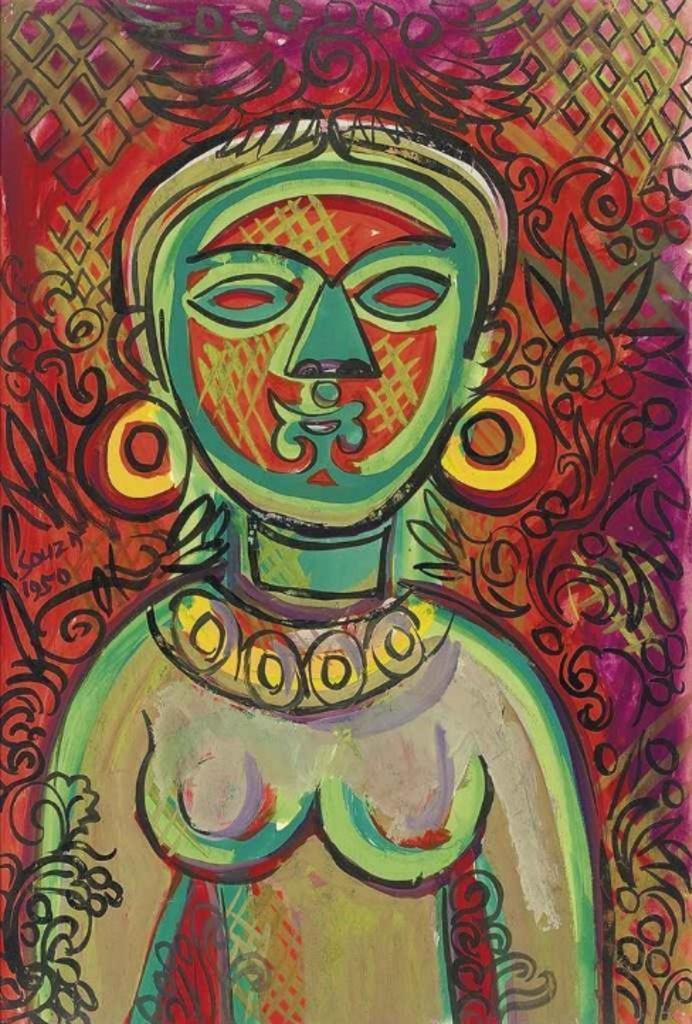Could you give a brief overview of what you see in this image? In this image there is a painting. There is a person. Background there is some design. 